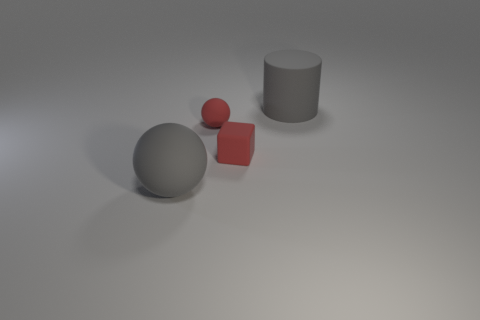The gray object that is behind the large gray object on the left side of the large cylinder is made of what material?
Offer a terse response. Rubber. How many matte objects are on the right side of the big rubber sphere and to the left of the cylinder?
Offer a terse response. 2. Is the number of big matte balls that are behind the tiny matte sphere the same as the number of big gray objects in front of the block?
Keep it short and to the point. No. Is the size of the gray object behind the small block the same as the gray thing in front of the rubber cylinder?
Ensure brevity in your answer.  Yes. The object that is behind the cube and left of the tiny red rubber block is made of what material?
Your answer should be compact. Rubber. Is the number of small blue cubes less than the number of big matte objects?
Give a very brief answer. Yes. There is a red ball that is behind the large rubber object that is left of the gray matte cylinder; how big is it?
Provide a succinct answer. Small. The large object behind the big rubber object left of the gray matte object on the right side of the small rubber ball is what shape?
Offer a very short reply. Cylinder. The large cylinder that is the same material as the small ball is what color?
Ensure brevity in your answer.  Gray. There is a matte block in front of the matte sphere that is behind the rubber object in front of the small block; what color is it?
Provide a short and direct response. Red. 